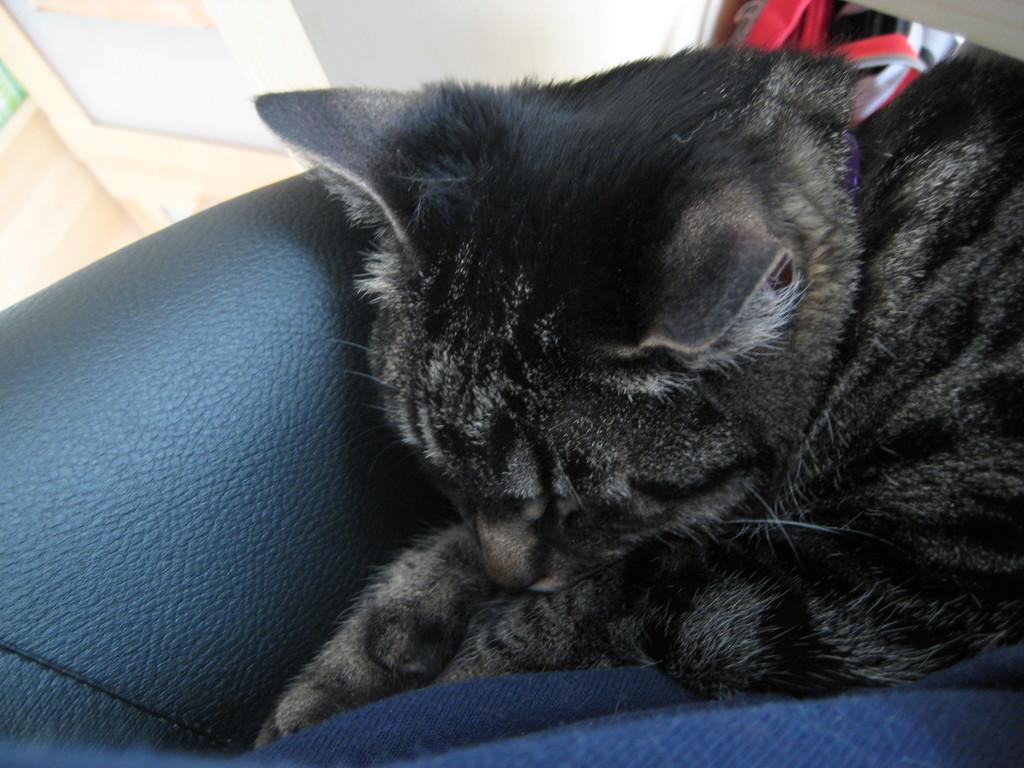What type of animal is present in the image? There is a cat in the image. Can you describe the object on the left side of the image? Unfortunately, the provided facts do not give any details about the object on the left side of the image. What is the material of the cloth at the bottom of the image? The facts do not specify the material of the cloth at the bottom of the image. How does the cat participate in the swimming competition in the image? There is no swimming competition or any indication of swimming in the image. The cat is simply present in the image. 